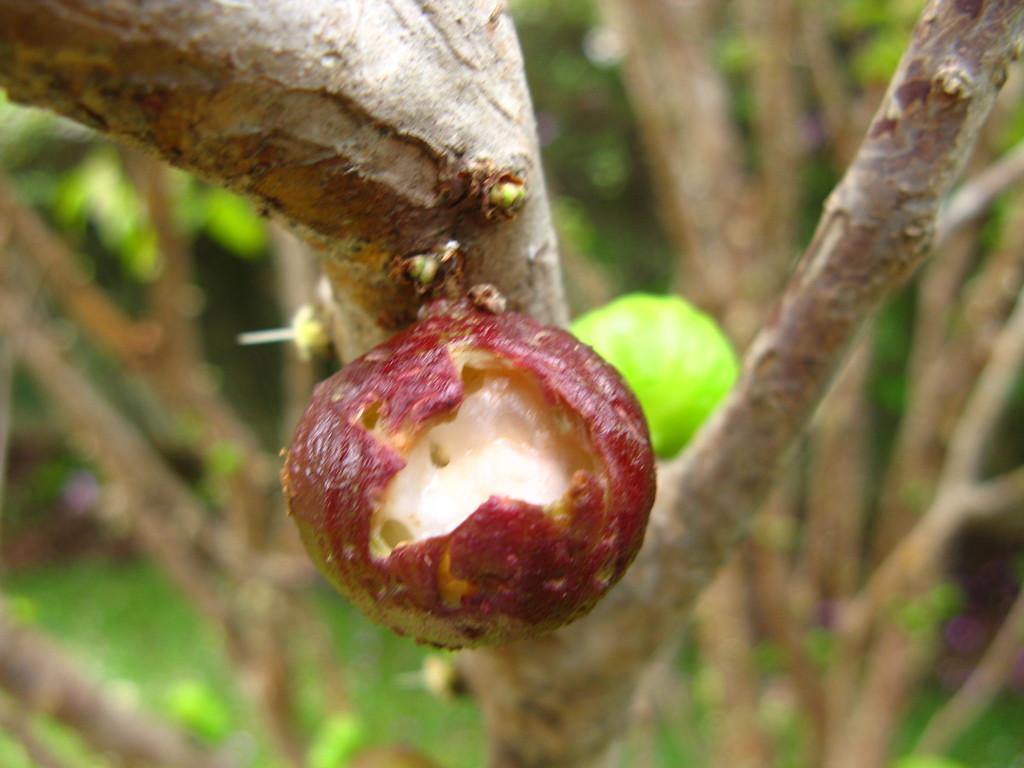What is the main subject of the image? There is a tree with fruit in the image. Can you describe the background of the image? The background is blurred. Are there any other trees visible in the image? Yes, there are additional trees visible in the background. What type of zebra can be seen grazing near the tree in the image? There is no zebra present in the image; it only features a tree with fruit and a blurred background. 